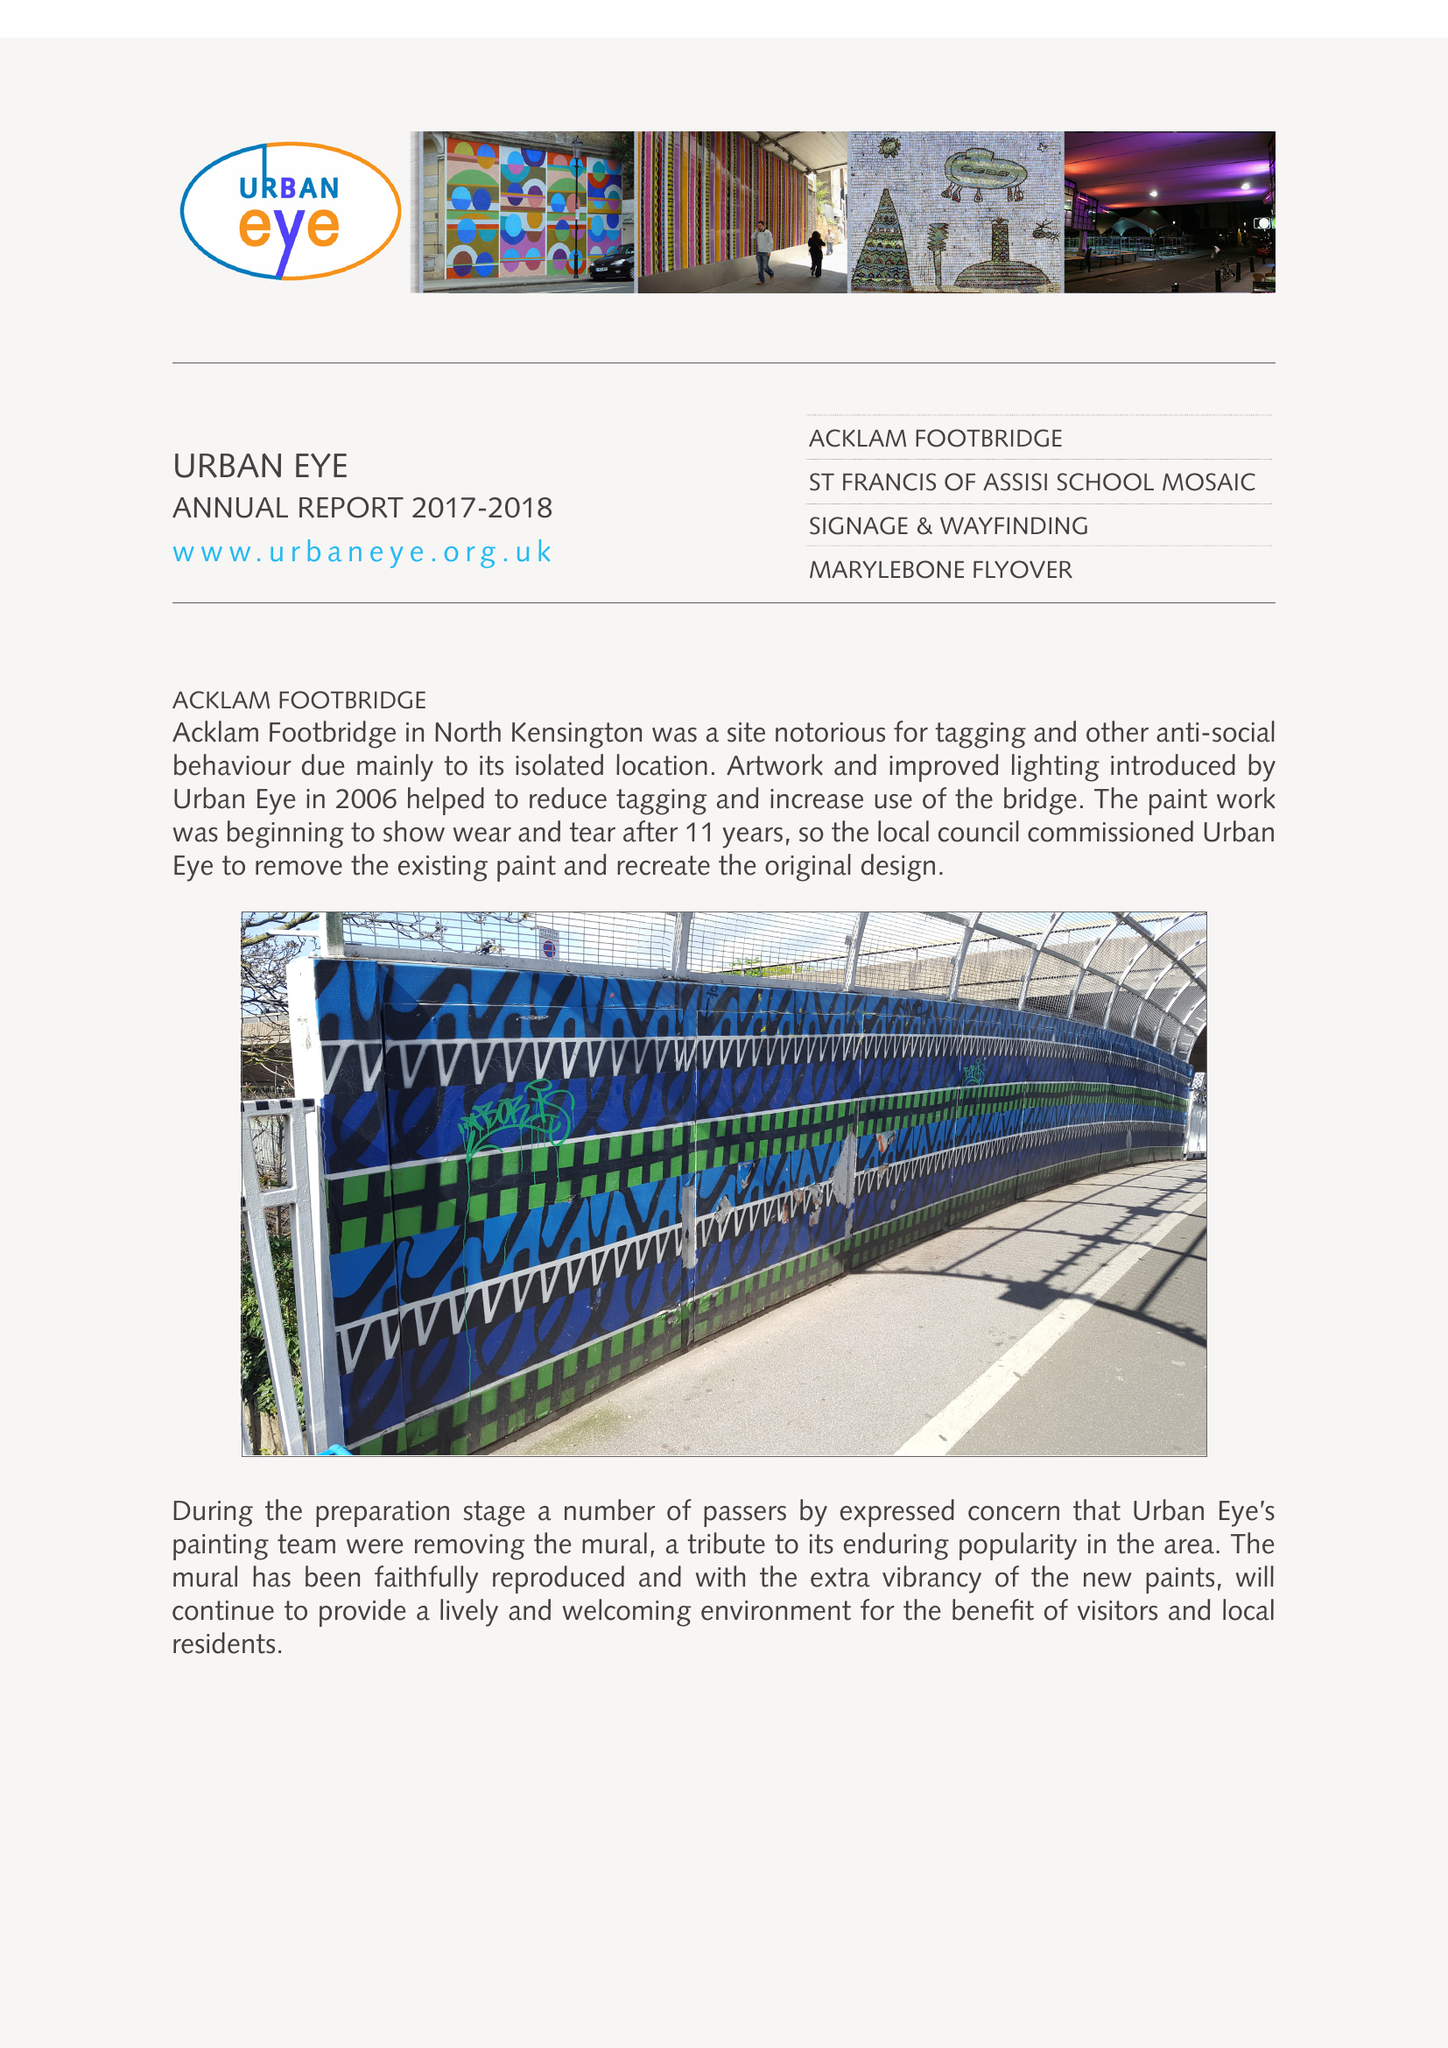What is the value for the income_annually_in_british_pounds?
Answer the question using a single word or phrase. 29568.00 